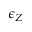Convert formula to latex. <formula><loc_0><loc_0><loc_500><loc_500>\epsilon _ { Z }</formula> 